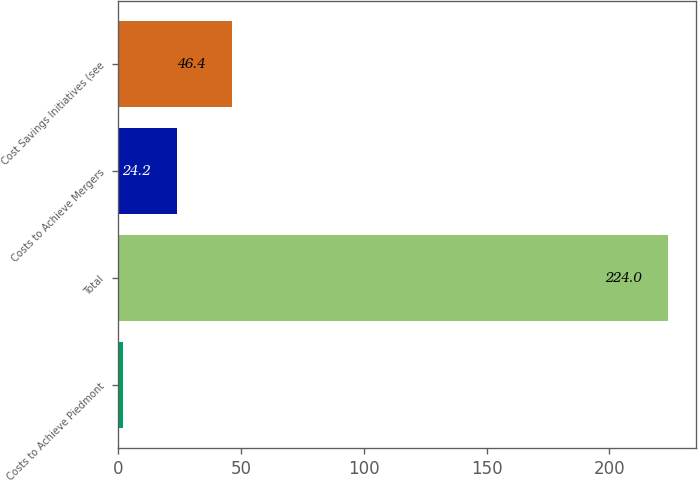Convert chart to OTSL. <chart><loc_0><loc_0><loc_500><loc_500><bar_chart><fcel>Costs to Achieve Piedmont<fcel>Total<fcel>Costs to Achieve Mergers<fcel>Cost Savings Initiatives (see<nl><fcel>2<fcel>224<fcel>24.2<fcel>46.4<nl></chart> 